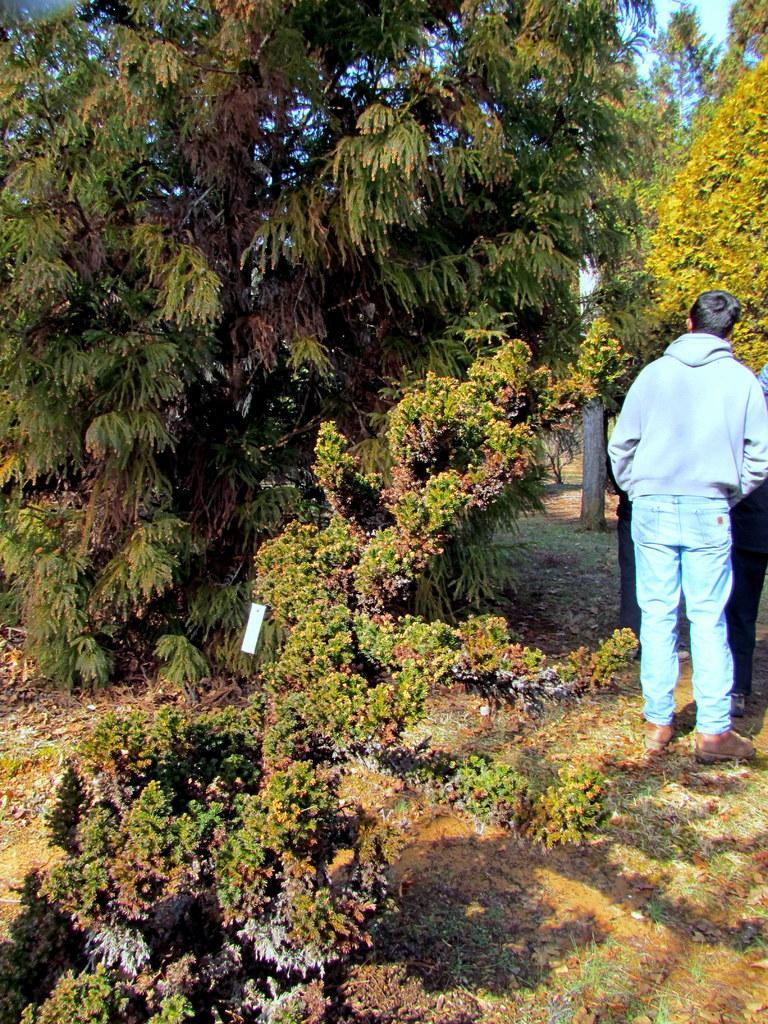Describe this image in one or two sentences. In the image there are some trees and plants. On the right side of the image two persons are standing. 